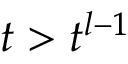Convert formula to latex. <formula><loc_0><loc_0><loc_500><loc_500>t > t ^ { l - 1 }</formula> 